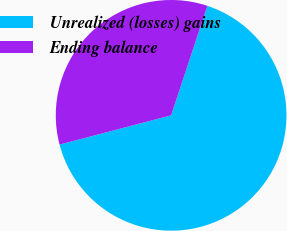Convert chart. <chart><loc_0><loc_0><loc_500><loc_500><pie_chart><fcel>Unrealized (losses) gains<fcel>Ending balance<nl><fcel>65.83%<fcel>34.17%<nl></chart> 